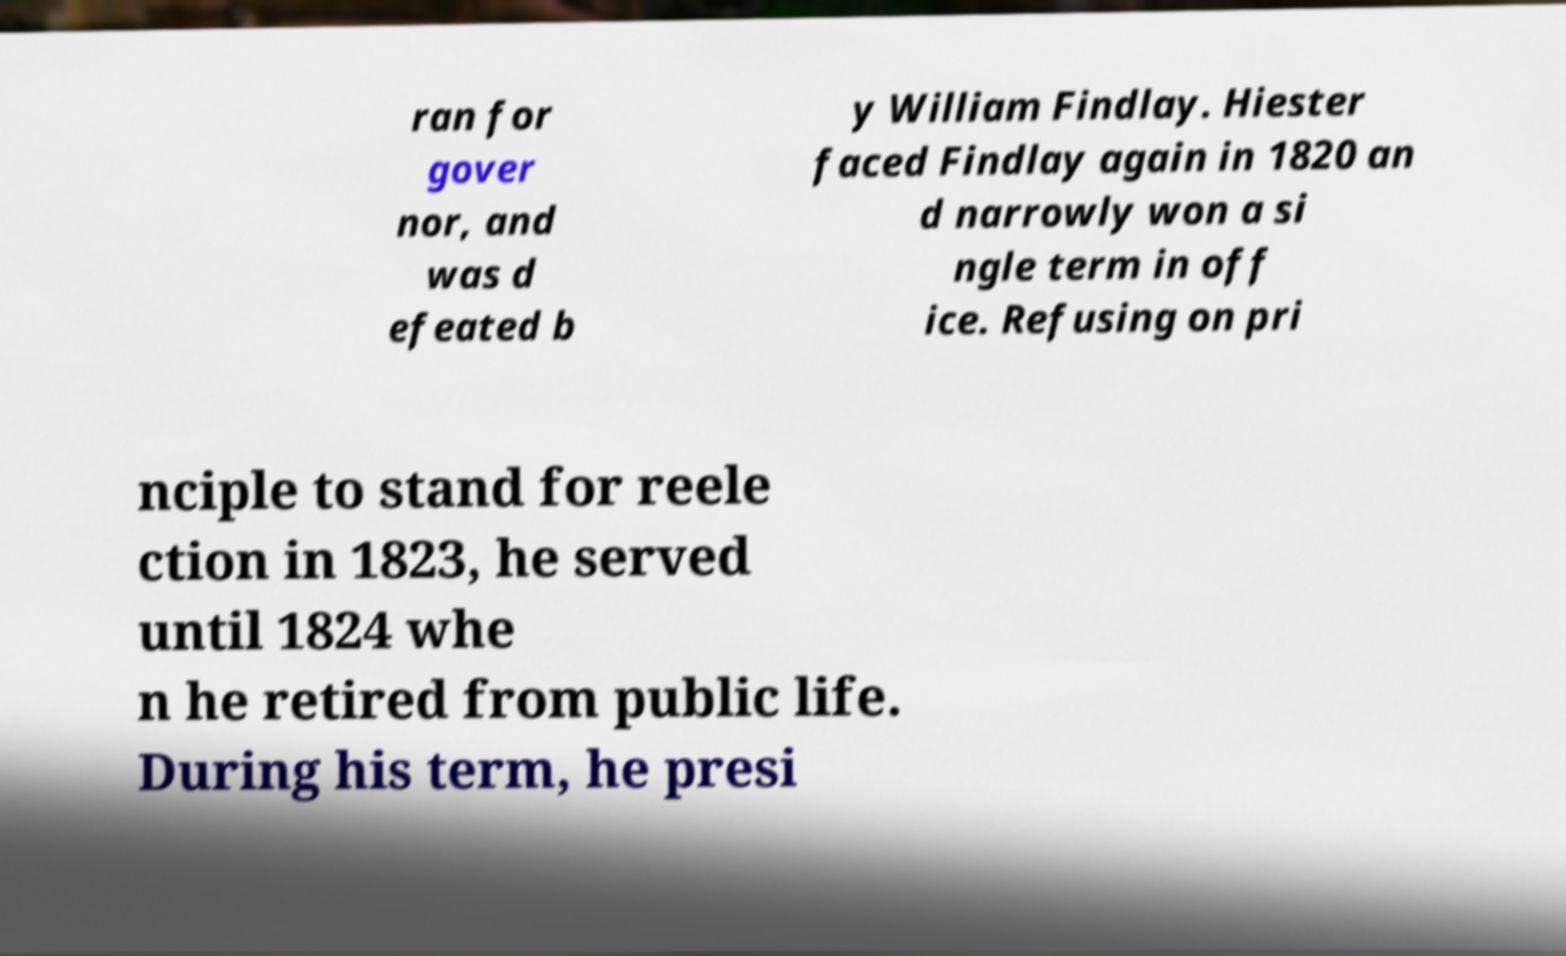Can you accurately transcribe the text from the provided image for me? ran for gover nor, and was d efeated b y William Findlay. Hiester faced Findlay again in 1820 an d narrowly won a si ngle term in off ice. Refusing on pri nciple to stand for reele ction in 1823, he served until 1824 whe n he retired from public life. During his term, he presi 